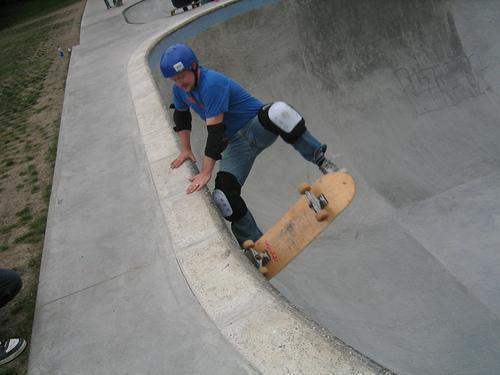What is the area the man is skating in usually called?
Answer the question by selecting the correct answer among the 4 following choices.
Options: Arena, bowl, deck, zoo. Bowl. 